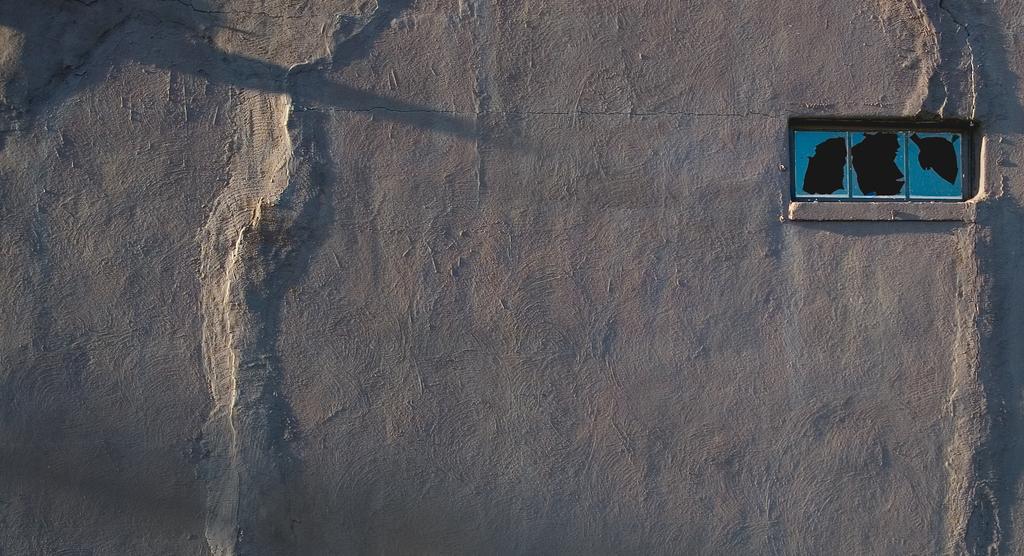Can you describe this image briefly? In this picture it might be a satellite image where I can see the land, open area. On the right I can see some rectangle box, in that I can see the water. 